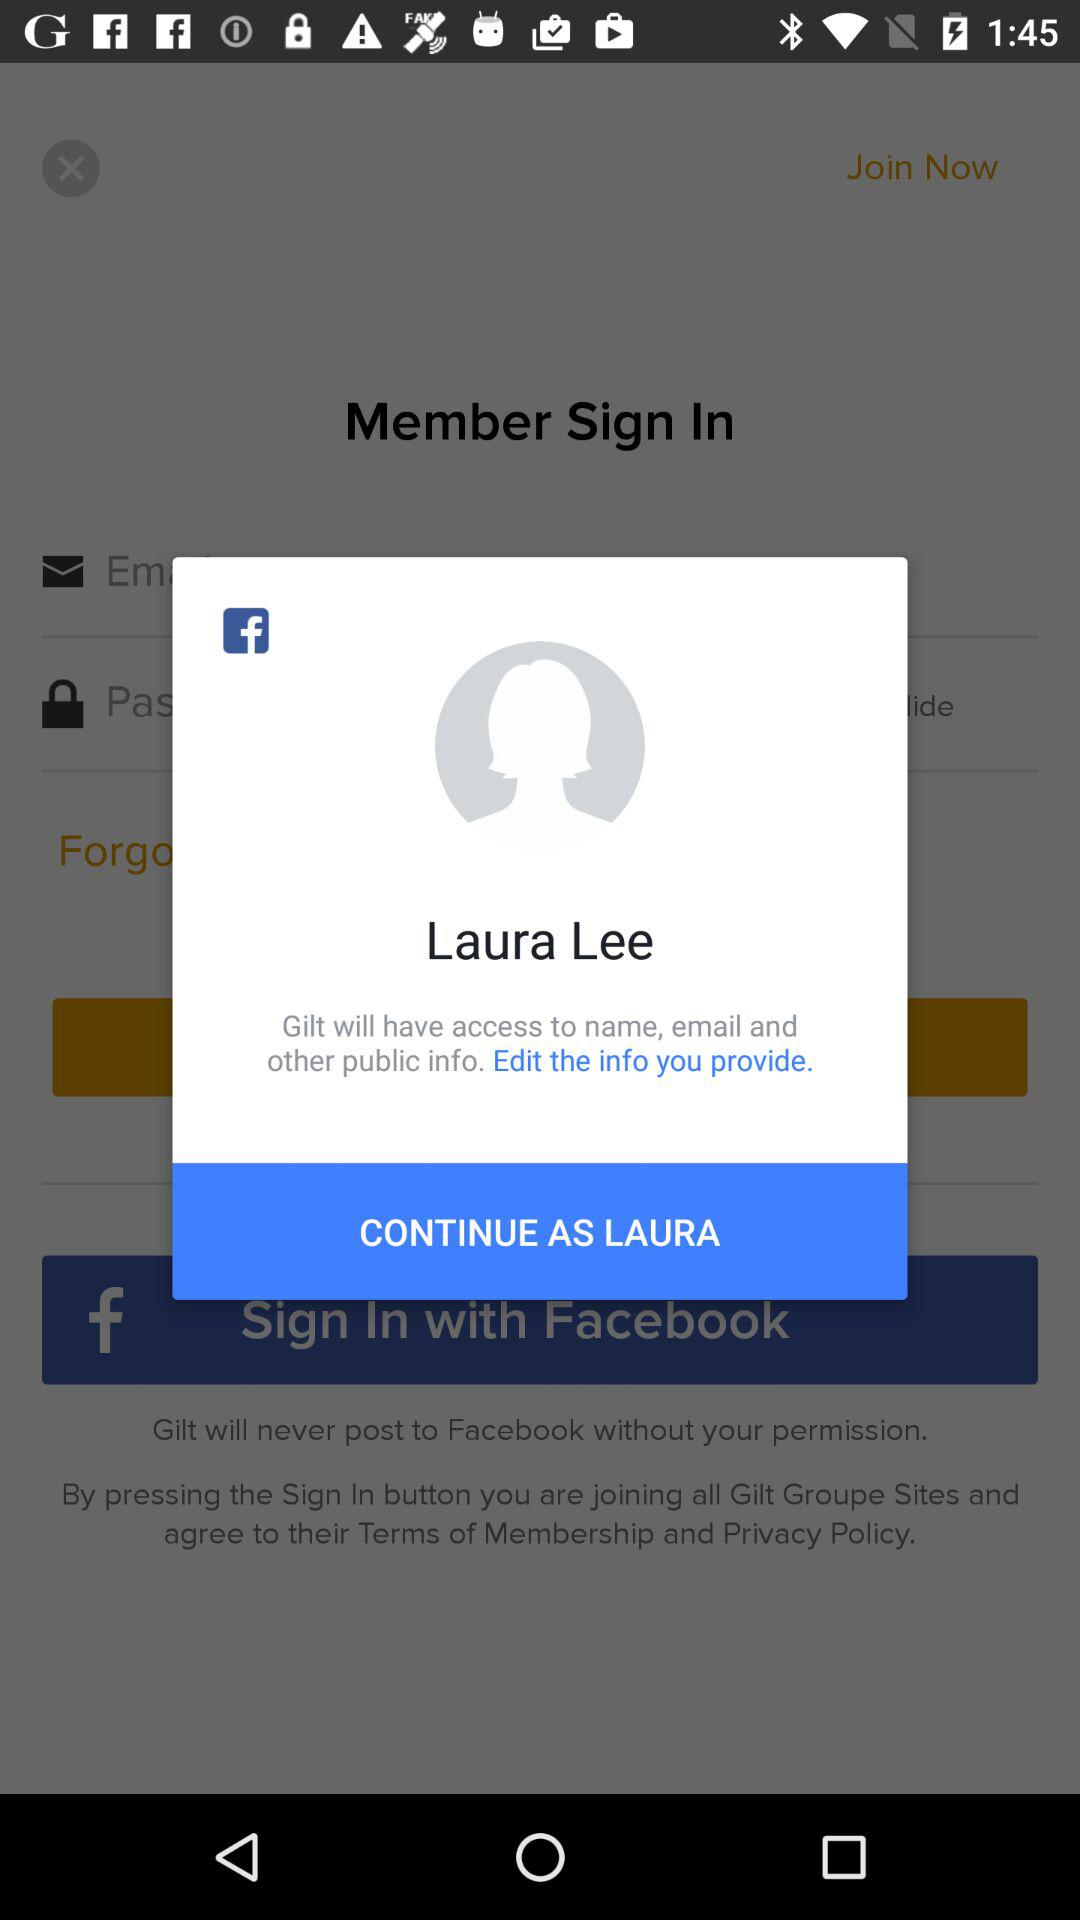Who is signing in? The person who is signing in is Laura Lee. 